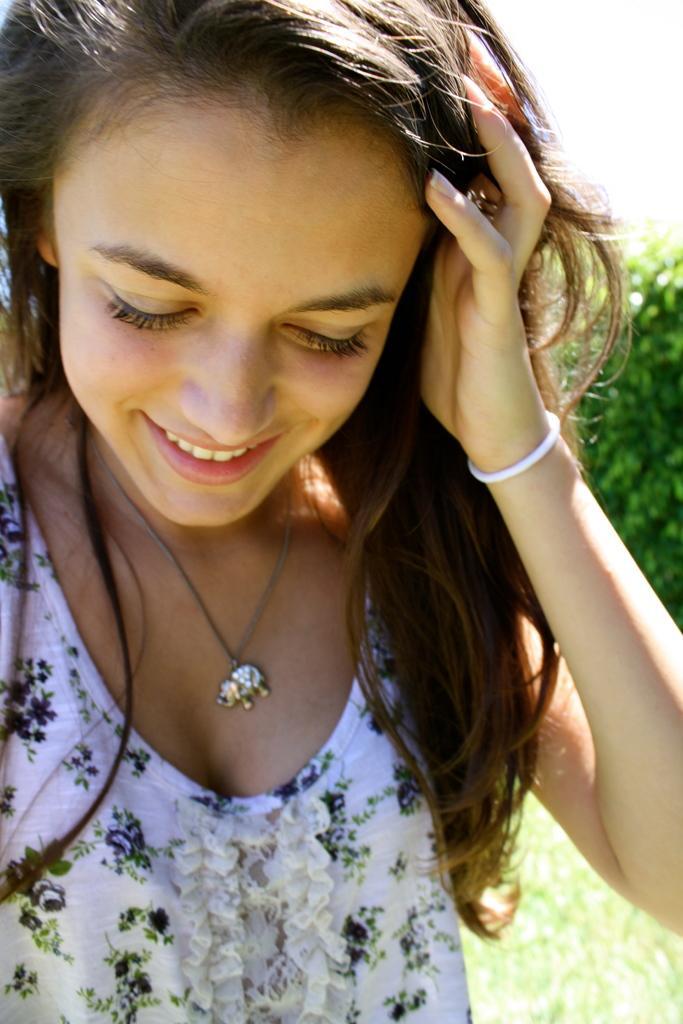Can you describe this image briefly? In this picture we can see a girl is smiling in the front, at the bottom there is grass, we can see a tree in the background. 